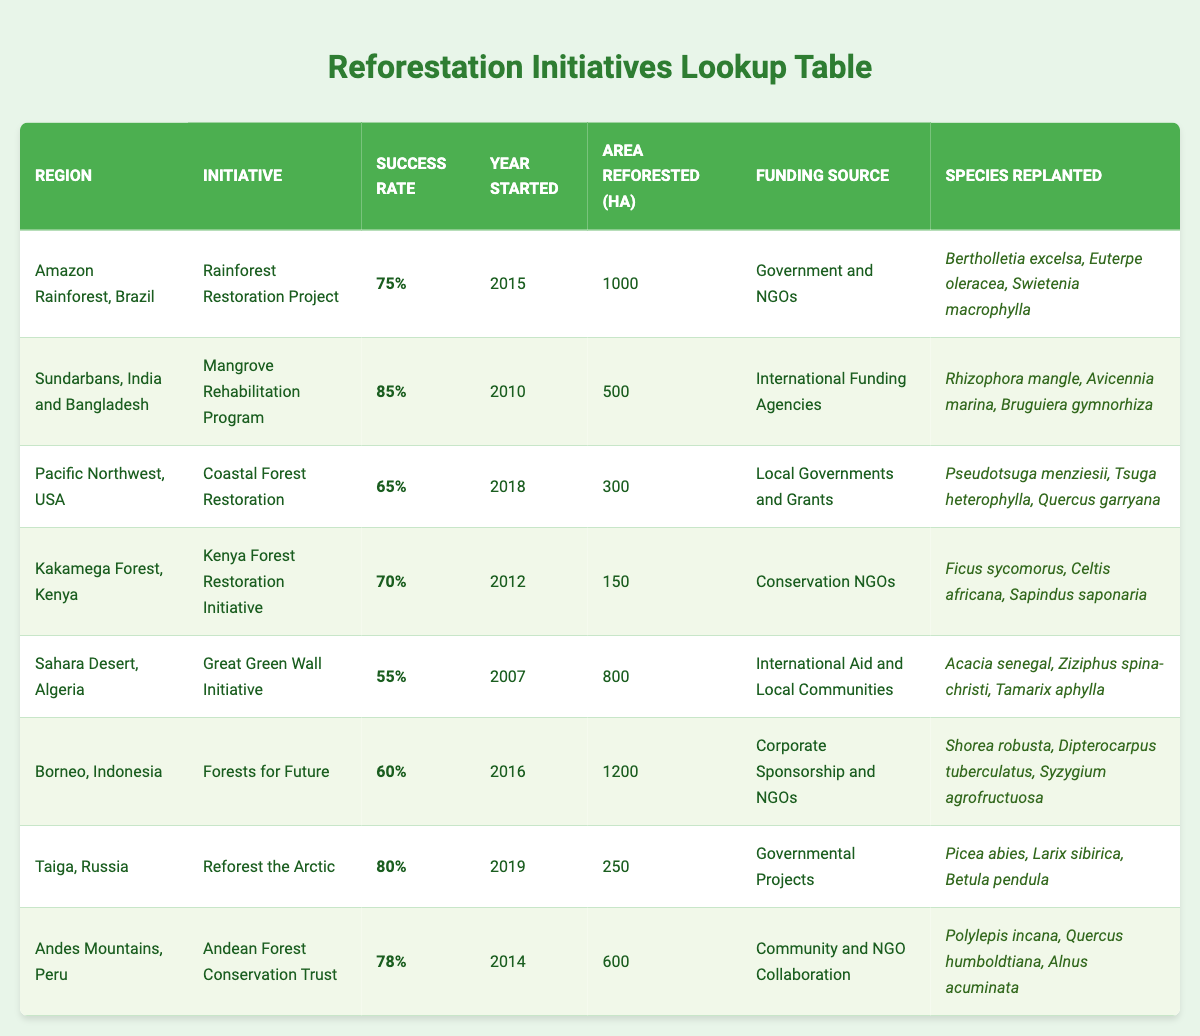What is the success rate of the Mangrove Rehabilitation Program? The success rate of the Mangrove Rehabilitation Program, which is located in the Sundarbans, India and Bangladesh, is listed directly in the table as 85%.
Answer: 85% Which reforestation initiative has the highest success rate? By comparing the success rates listed in the table, the Mangrove Rehabilitation Program has the highest success rate at 85%.
Answer: Mangrove Rehabilitation Program What is the total area reforested by all initiatives combined? To find the total area reforested, we sum the areas from each initiative: 1000 + 500 + 300 + 150 + 800 + 1200 + 250 + 600 = 3800 hectares.
Answer: 3800 hectares Is the success rate of the Great Green Wall Initiative less than 60%? The success rate of the Great Green Wall Initiative is 55%, which is indeed less than 60%.
Answer: Yes How many hectares were reforested in the Pacific Northwest, USA? The table indicates that the area reforested in the Pacific Northwest, USA, is 300 hectares, as stated directly under that initiative.
Answer: 300 hectares Which region had the earliest reforestation initiative started, and what was its success rate? By reviewing the years listed in the table, the earliest initiative started is the Great Green Wall Initiative in 2007, which has a success rate of 55%.
Answer: Sahara Desert, Algeria; 55% What is the average success rate of all reforestation initiatives in Africa? There are two initiatives in Africa listed: the Kenya Forest Restoration Initiative (70%) and the Great Green Wall Initiative (55%). To find the average: (70 + 55) / 2 = 62.5%.
Answer: 62.5% How many different species were replanted in the Andean Forest Conservation Trust initiative? The Andean Forest Conservation Trust initiative lists three species replanted: Polylepis incana, Quercus humboldtiana, and Alnus acuminata.
Answer: 3 species Did the Coastal Forest Restoration initiative receive funding from international sources? According to the table, the Coastal Forest Restoration initiative received funding from Local Governments and Grants, which are not international sources.
Answer: No 